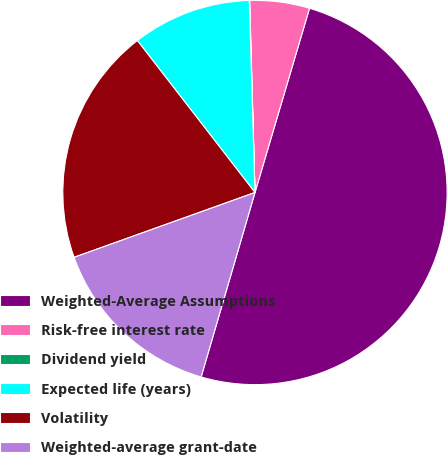Convert chart to OTSL. <chart><loc_0><loc_0><loc_500><loc_500><pie_chart><fcel>Weighted-Average Assumptions<fcel>Risk-free interest rate<fcel>Dividend yield<fcel>Expected life (years)<fcel>Volatility<fcel>Weighted-average grant-date<nl><fcel>49.93%<fcel>5.02%<fcel>0.03%<fcel>10.01%<fcel>19.99%<fcel>15.0%<nl></chart> 